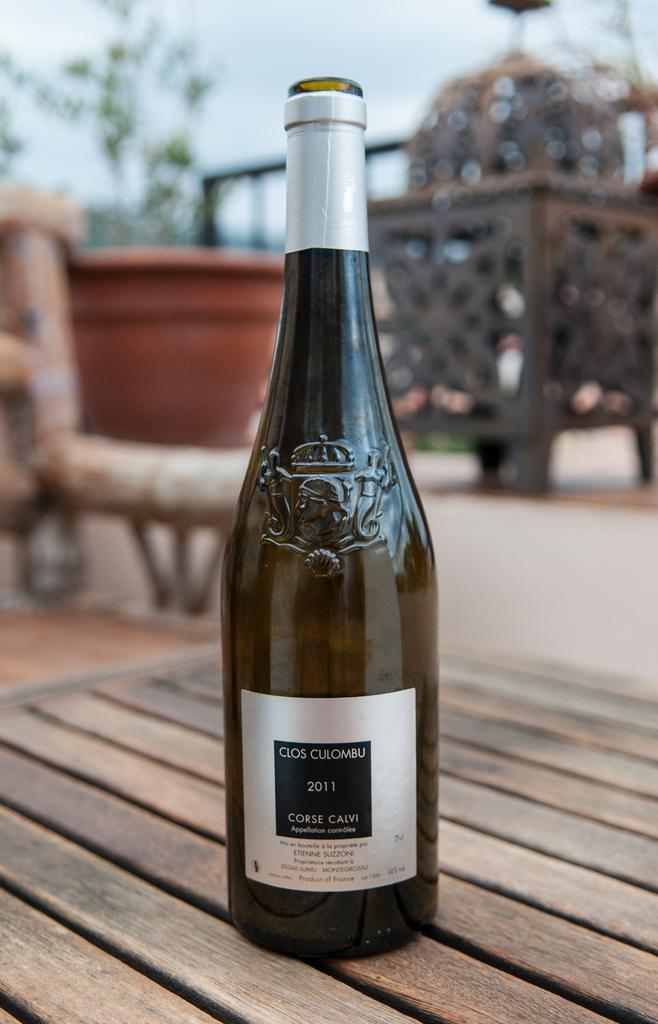<image>
Create a compact narrative representing the image presented. Wine in a bottle from the year of 2011 